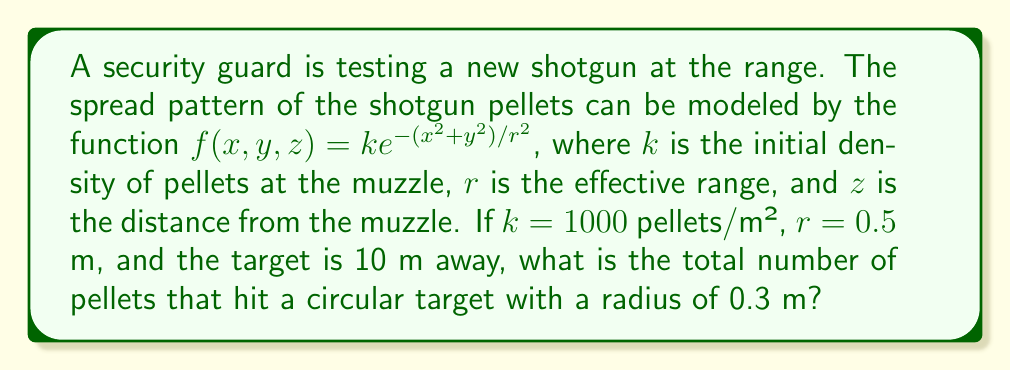What is the answer to this math problem? To solve this problem, we need to use multivariable calculus, specifically a double integral in polar coordinates.

Step 1: Set up the double integral
The total number of pellets hitting the target is the volume under the surface $f(x,y,z)$ over the circular target area. We can express this as:

$$N = \int\int_A f(x,y,10) \, dA$$

where $A$ is the circular target area.

Step 2: Convert to polar coordinates
Let $x = \rho \cos\theta$ and $y = \rho \sin\theta$. The Jacobian of this transformation is $\rho$. The integral becomes:

$$N = \int_0^{2\pi} \int_0^{0.3} f(\rho\cos\theta, \rho\sin\theta, 10) \, \rho \, d\rho \, d\theta$$

Step 3: Substitute the function
$$N = \int_0^{2\pi} \int_0^{0.3} 1000e^{-(\rho^2\cos^2\theta + \rho^2\sin^2\theta)/(0.5^2)} \, \rho \, d\rho \, d\theta$$

Step 4: Simplify
Note that $\cos^2\theta + \sin^2\theta = 1$, so we can simplify:

$$N = 1000 \int_0^{2\pi} \int_0^{0.3} e^{-4\rho^2} \, \rho \, d\rho \, d\theta$$

Step 5: Evaluate the inner integral
$$N = 1000 \int_0^{2\pi} \left[-\frac{1}{8}e^{-4\rho^2}\right]_0^{0.3} \, d\theta$$
$$N = 1000 \int_0^{2\pi} \left(-\frac{1}{8}e^{-4(0.3)^2} + \frac{1}{8}\right) \, d\theta$$

Step 6: Evaluate the outer integral
$$N = 1000 \cdot 2\pi \cdot \left(-\frac{1}{8}e^{-0.36} + \frac{1}{8}\right)$$

Step 7: Calculate the final result
$$N \approx 220.6$$

Since we can't have a fractional number of pellets, we round to the nearest whole number.
Answer: 221 pellets 